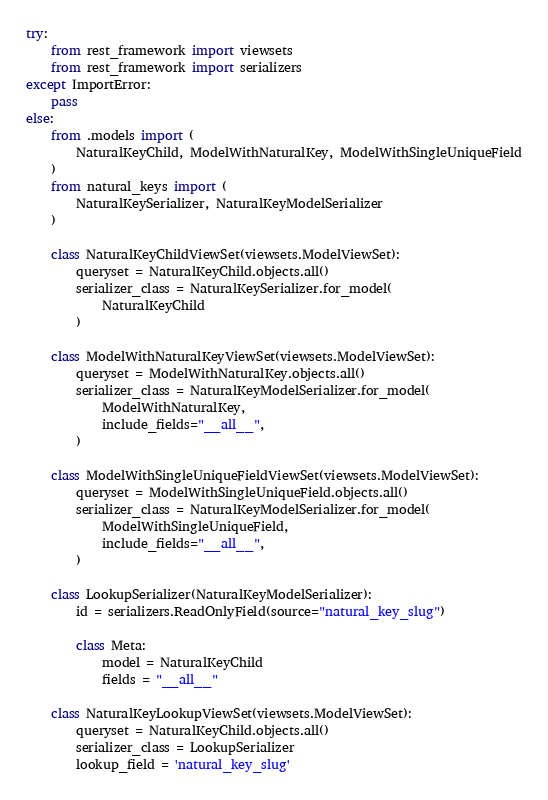Convert code to text. <code><loc_0><loc_0><loc_500><loc_500><_Python_>try:
    from rest_framework import viewsets
    from rest_framework import serializers
except ImportError:
    pass
else:
    from .models import (
        NaturalKeyChild, ModelWithNaturalKey, ModelWithSingleUniqueField
    )
    from natural_keys import (
        NaturalKeySerializer, NaturalKeyModelSerializer
    )

    class NaturalKeyChildViewSet(viewsets.ModelViewSet):
        queryset = NaturalKeyChild.objects.all()
        serializer_class = NaturalKeySerializer.for_model(
            NaturalKeyChild
        )

    class ModelWithNaturalKeyViewSet(viewsets.ModelViewSet):
        queryset = ModelWithNaturalKey.objects.all()
        serializer_class = NaturalKeyModelSerializer.for_model(
            ModelWithNaturalKey,
            include_fields="__all__",
        )

    class ModelWithSingleUniqueFieldViewSet(viewsets.ModelViewSet):
        queryset = ModelWithSingleUniqueField.objects.all()
        serializer_class = NaturalKeyModelSerializer.for_model(
            ModelWithSingleUniqueField,
            include_fields="__all__",
        )

    class LookupSerializer(NaturalKeyModelSerializer):
        id = serializers.ReadOnlyField(source="natural_key_slug")

        class Meta:
            model = NaturalKeyChild
            fields = "__all__"

    class NaturalKeyLookupViewSet(viewsets.ModelViewSet):
        queryset = NaturalKeyChild.objects.all()
        serializer_class = LookupSerializer
        lookup_field = 'natural_key_slug'
</code> 